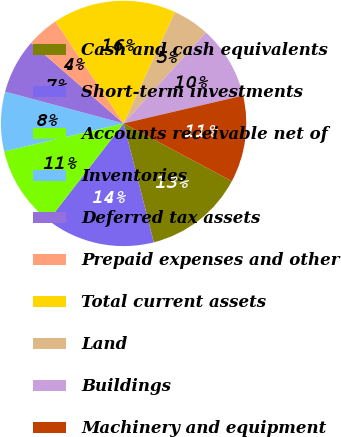<chart> <loc_0><loc_0><loc_500><loc_500><pie_chart><fcel>Cash and cash equivalents<fcel>Short-term investments<fcel>Accounts receivable net of<fcel>Inventories<fcel>Deferred tax assets<fcel>Prepaid expenses and other<fcel>Total current assets<fcel>Land<fcel>Buildings<fcel>Machinery and equipment<nl><fcel>13.25%<fcel>14.45%<fcel>10.84%<fcel>7.83%<fcel>7.23%<fcel>4.22%<fcel>16.26%<fcel>4.82%<fcel>9.64%<fcel>11.44%<nl></chart> 